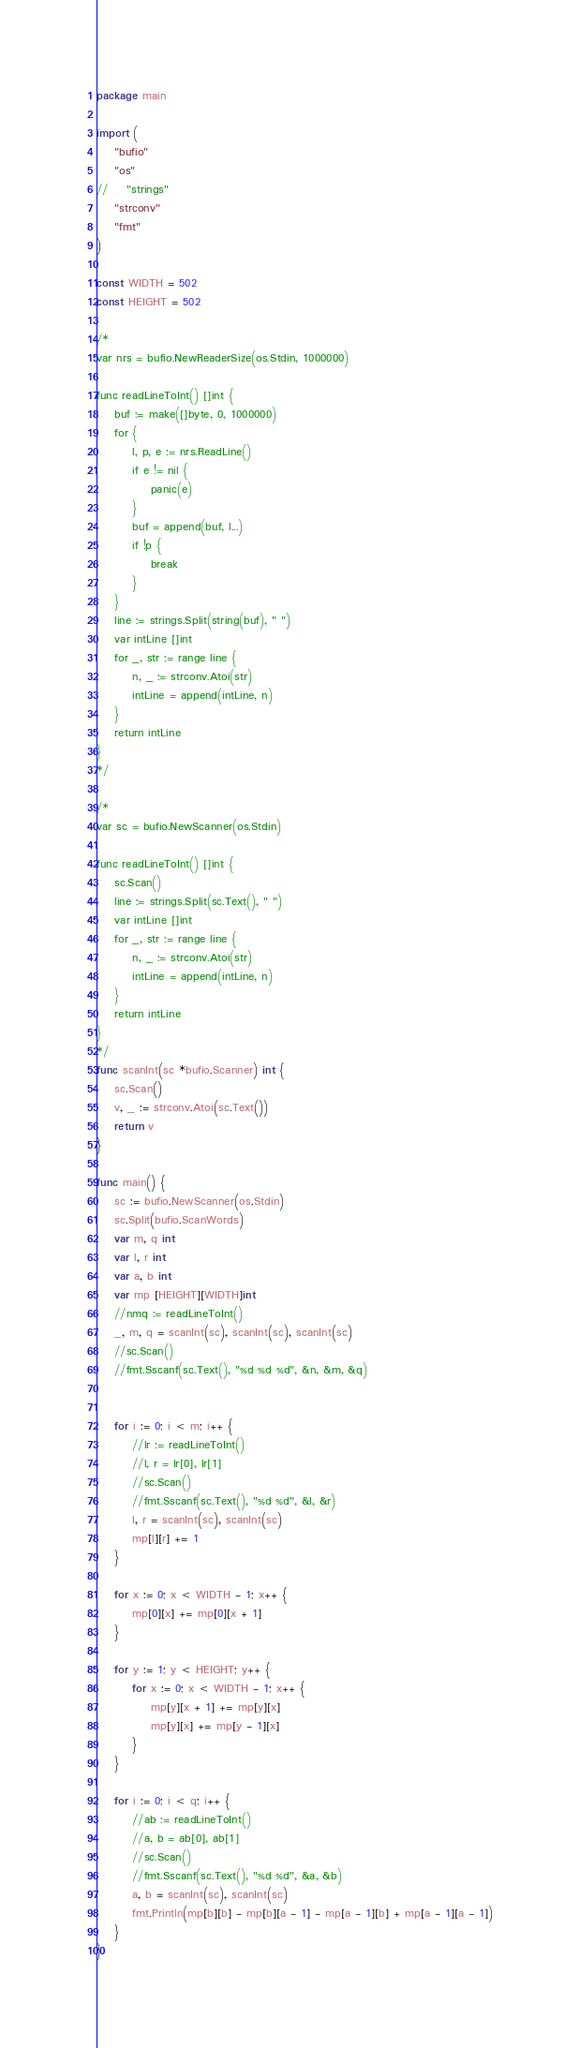Convert code to text. <code><loc_0><loc_0><loc_500><loc_500><_Go_>package main

import (
    "bufio"
    "os"
//    "strings"
    "strconv"
    "fmt"
)

const WIDTH = 502
const HEIGHT = 502

/*
var nrs = bufio.NewReaderSize(os.Stdin, 1000000)

func readLineToInt() []int {
    buf := make([]byte, 0, 1000000)
    for {
        l, p, e := nrs.ReadLine()
        if e != nil {
            panic(e)
        }
        buf = append(buf, l...)
        if !p {
            break
        }
    }
    line := strings.Split(string(buf), " ")
    var intLine []int
    for _, str := range line {
        n, _ := strconv.Atoi(str)
        intLine = append(intLine, n)
    }
    return intLine
}
*/

/*
var sc = bufio.NewScanner(os.Stdin)

func readLineToInt() []int {
    sc.Scan()
    line := strings.Split(sc.Text(), " ")
    var intLine []int
    for _, str := range line {
        n, _ := strconv.Atoi(str)
        intLine = append(intLine, n)
    }
    return intLine
}
*/
func scanInt(sc *bufio.Scanner) int {
    sc.Scan()
    v, _ := strconv.Atoi(sc.Text())
    return v
}

func main() {
    sc := bufio.NewScanner(os.Stdin)
    sc.Split(bufio.ScanWords)
    var m, q int
    var l, r int
    var a, b int
    var mp [HEIGHT][WIDTH]int
    //nmq := readLineToInt()
    _, m, q = scanInt(sc), scanInt(sc), scanInt(sc)
    //sc.Scan()
    //fmt.Sscanf(sc.Text(), "%d %d %d", &n, &m, &q)


    for i := 0; i < m; i++ {
        //lr := readLineToInt()
        //l, r = lr[0], lr[1]
        //sc.Scan()
        //fmt.Sscanf(sc.Text(), "%d %d", &l, &r)
        l, r = scanInt(sc), scanInt(sc)
        mp[l][r] += 1
    }

    for x := 0; x < WIDTH - 1; x++ {
        mp[0][x] += mp[0][x + 1]
    }

    for y := 1; y < HEIGHT; y++ {
        for x := 0; x < WIDTH - 1; x++ {
            mp[y][x + 1] += mp[y][x]
            mp[y][x] += mp[y - 1][x]
        }
    }

    for i := 0; i < q; i++ {
        //ab := readLineToInt()
        //a, b = ab[0], ab[1]
        //sc.Scan()
        //fmt.Sscanf(sc.Text(), "%d %d", &a, &b)
        a, b = scanInt(sc), scanInt(sc)
        fmt.Println(mp[b][b] - mp[b][a - 1] - mp[a - 1][b] + mp[a - 1][a - 1])
    }
}</code> 